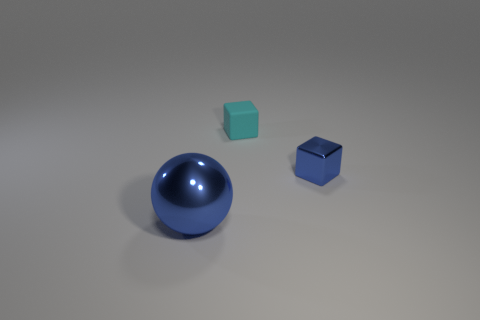Add 2 cubes. How many objects exist? 5 Subtract all cyan cubes. How many cubes are left? 1 Subtract all balls. How many objects are left? 2 Subtract all cyan cylinders. Subtract all large blue metallic things. How many objects are left? 2 Add 2 tiny shiny cubes. How many tiny shiny cubes are left? 3 Add 3 blue shiny blocks. How many blue shiny blocks exist? 4 Subtract 0 purple blocks. How many objects are left? 3 